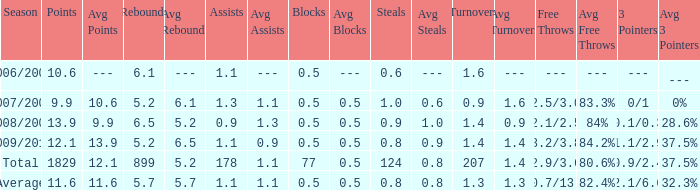What is the maximum rebounds when there are 0.9 steals and fewer than 1.4 turnovers? None. 